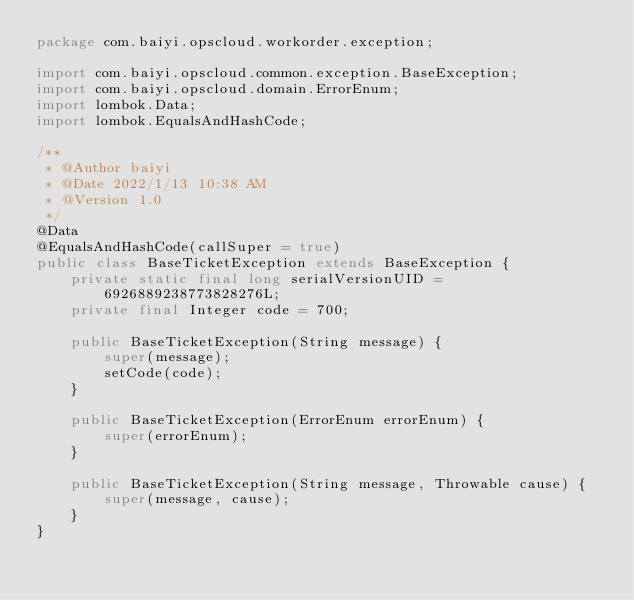Convert code to text. <code><loc_0><loc_0><loc_500><loc_500><_Java_>package com.baiyi.opscloud.workorder.exception;

import com.baiyi.opscloud.common.exception.BaseException;
import com.baiyi.opscloud.domain.ErrorEnum;
import lombok.Data;
import lombok.EqualsAndHashCode;

/**
 * @Author baiyi
 * @Date 2022/1/13 10:38 AM
 * @Version 1.0
 */
@Data
@EqualsAndHashCode(callSuper = true)
public class BaseTicketException extends BaseException {
    private static final long serialVersionUID = 6926889238773828276L;
    private final Integer code = 700;

    public BaseTicketException(String message) {
        super(message);
        setCode(code);
    }

    public BaseTicketException(ErrorEnum errorEnum) {
        super(errorEnum);
    }

    public BaseTicketException(String message, Throwable cause) {
        super(message, cause);
    }
}

</code> 